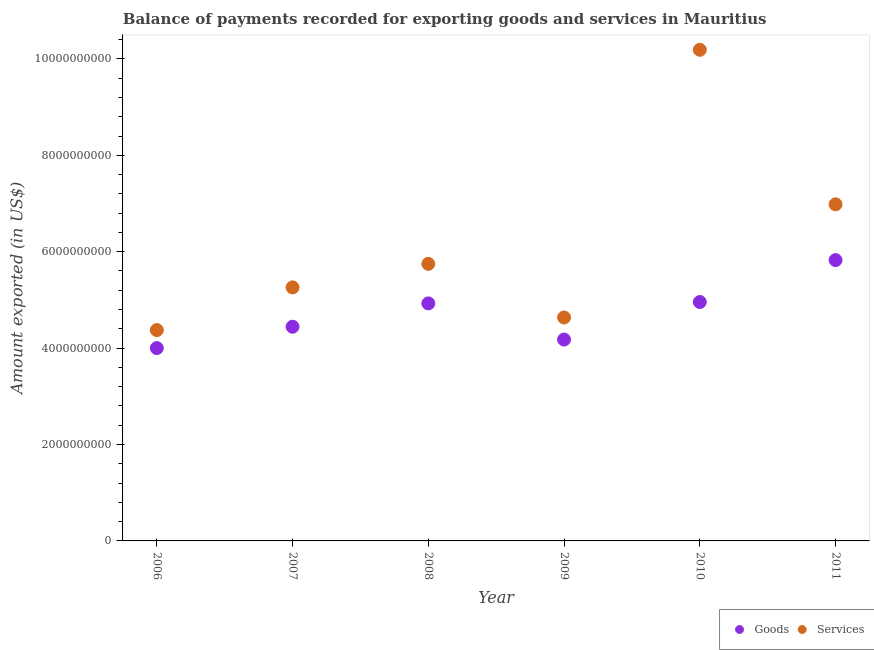How many different coloured dotlines are there?
Make the answer very short. 2. What is the amount of goods exported in 2007?
Your answer should be compact. 4.44e+09. Across all years, what is the maximum amount of goods exported?
Offer a very short reply. 5.83e+09. Across all years, what is the minimum amount of goods exported?
Make the answer very short. 4.00e+09. In which year was the amount of services exported maximum?
Your answer should be very brief. 2010. What is the total amount of services exported in the graph?
Provide a short and direct response. 3.72e+1. What is the difference between the amount of goods exported in 2008 and that in 2011?
Your answer should be compact. -8.98e+08. What is the difference between the amount of goods exported in 2010 and the amount of services exported in 2008?
Offer a terse response. -7.91e+08. What is the average amount of goods exported per year?
Offer a very short reply. 4.72e+09. In the year 2007, what is the difference between the amount of services exported and amount of goods exported?
Provide a succinct answer. 8.16e+08. What is the ratio of the amount of goods exported in 2008 to that in 2009?
Make the answer very short. 1.18. Is the difference between the amount of goods exported in 2006 and 2008 greater than the difference between the amount of services exported in 2006 and 2008?
Your answer should be very brief. Yes. What is the difference between the highest and the second highest amount of services exported?
Your response must be concise. 3.21e+09. What is the difference between the highest and the lowest amount of goods exported?
Keep it short and to the point. 1.83e+09. In how many years, is the amount of goods exported greater than the average amount of goods exported taken over all years?
Your response must be concise. 3. Is the sum of the amount of services exported in 2010 and 2011 greater than the maximum amount of goods exported across all years?
Keep it short and to the point. Yes. Does the amount of goods exported monotonically increase over the years?
Your response must be concise. No. Is the amount of goods exported strictly greater than the amount of services exported over the years?
Your answer should be compact. No. Is the amount of services exported strictly less than the amount of goods exported over the years?
Provide a succinct answer. No. How many dotlines are there?
Provide a short and direct response. 2. What is the difference between two consecutive major ticks on the Y-axis?
Your answer should be compact. 2.00e+09. Where does the legend appear in the graph?
Your response must be concise. Bottom right. How are the legend labels stacked?
Provide a short and direct response. Horizontal. What is the title of the graph?
Keep it short and to the point. Balance of payments recorded for exporting goods and services in Mauritius. Does "International Visitors" appear as one of the legend labels in the graph?
Give a very brief answer. No. What is the label or title of the Y-axis?
Keep it short and to the point. Amount exported (in US$). What is the Amount exported (in US$) of Goods in 2006?
Provide a short and direct response. 4.00e+09. What is the Amount exported (in US$) of Services in 2006?
Offer a very short reply. 4.37e+09. What is the Amount exported (in US$) in Goods in 2007?
Provide a succinct answer. 4.44e+09. What is the Amount exported (in US$) of Services in 2007?
Your response must be concise. 5.26e+09. What is the Amount exported (in US$) in Goods in 2008?
Ensure brevity in your answer.  4.93e+09. What is the Amount exported (in US$) in Services in 2008?
Provide a short and direct response. 5.75e+09. What is the Amount exported (in US$) of Goods in 2009?
Keep it short and to the point. 4.18e+09. What is the Amount exported (in US$) in Services in 2009?
Make the answer very short. 4.64e+09. What is the Amount exported (in US$) of Goods in 2010?
Offer a terse response. 4.96e+09. What is the Amount exported (in US$) of Services in 2010?
Your answer should be very brief. 1.02e+1. What is the Amount exported (in US$) in Goods in 2011?
Give a very brief answer. 5.83e+09. What is the Amount exported (in US$) of Services in 2011?
Your response must be concise. 6.98e+09. Across all years, what is the maximum Amount exported (in US$) in Goods?
Keep it short and to the point. 5.83e+09. Across all years, what is the maximum Amount exported (in US$) in Services?
Provide a short and direct response. 1.02e+1. Across all years, what is the minimum Amount exported (in US$) in Goods?
Give a very brief answer. 4.00e+09. Across all years, what is the minimum Amount exported (in US$) of Services?
Provide a succinct answer. 4.37e+09. What is the total Amount exported (in US$) in Goods in the graph?
Ensure brevity in your answer.  2.83e+1. What is the total Amount exported (in US$) in Services in the graph?
Your answer should be compact. 3.72e+1. What is the difference between the Amount exported (in US$) in Goods in 2006 and that in 2007?
Ensure brevity in your answer.  -4.43e+08. What is the difference between the Amount exported (in US$) in Services in 2006 and that in 2007?
Provide a succinct answer. -8.85e+08. What is the difference between the Amount exported (in US$) of Goods in 2006 and that in 2008?
Your answer should be very brief. -9.28e+08. What is the difference between the Amount exported (in US$) of Services in 2006 and that in 2008?
Your response must be concise. -1.37e+09. What is the difference between the Amount exported (in US$) of Goods in 2006 and that in 2009?
Your response must be concise. -1.77e+08. What is the difference between the Amount exported (in US$) in Services in 2006 and that in 2009?
Give a very brief answer. -2.61e+08. What is the difference between the Amount exported (in US$) in Goods in 2006 and that in 2010?
Offer a terse response. -9.56e+08. What is the difference between the Amount exported (in US$) of Services in 2006 and that in 2010?
Provide a short and direct response. -5.81e+09. What is the difference between the Amount exported (in US$) of Goods in 2006 and that in 2011?
Give a very brief answer. -1.83e+09. What is the difference between the Amount exported (in US$) in Services in 2006 and that in 2011?
Your answer should be compact. -2.61e+09. What is the difference between the Amount exported (in US$) of Goods in 2007 and that in 2008?
Provide a short and direct response. -4.85e+08. What is the difference between the Amount exported (in US$) in Services in 2007 and that in 2008?
Make the answer very short. -4.88e+08. What is the difference between the Amount exported (in US$) in Goods in 2007 and that in 2009?
Give a very brief answer. 2.66e+08. What is the difference between the Amount exported (in US$) in Services in 2007 and that in 2009?
Give a very brief answer. 6.24e+08. What is the difference between the Amount exported (in US$) in Goods in 2007 and that in 2010?
Provide a succinct answer. -5.14e+08. What is the difference between the Amount exported (in US$) in Services in 2007 and that in 2010?
Offer a very short reply. -4.93e+09. What is the difference between the Amount exported (in US$) in Goods in 2007 and that in 2011?
Offer a very short reply. -1.38e+09. What is the difference between the Amount exported (in US$) in Services in 2007 and that in 2011?
Provide a succinct answer. -1.72e+09. What is the difference between the Amount exported (in US$) of Goods in 2008 and that in 2009?
Give a very brief answer. 7.50e+08. What is the difference between the Amount exported (in US$) in Services in 2008 and that in 2009?
Offer a terse response. 1.11e+09. What is the difference between the Amount exported (in US$) in Goods in 2008 and that in 2010?
Offer a very short reply. -2.88e+07. What is the difference between the Amount exported (in US$) in Services in 2008 and that in 2010?
Offer a very short reply. -4.44e+09. What is the difference between the Amount exported (in US$) of Goods in 2008 and that in 2011?
Ensure brevity in your answer.  -8.98e+08. What is the difference between the Amount exported (in US$) of Services in 2008 and that in 2011?
Provide a short and direct response. -1.24e+09. What is the difference between the Amount exported (in US$) of Goods in 2009 and that in 2010?
Offer a terse response. -7.79e+08. What is the difference between the Amount exported (in US$) of Services in 2009 and that in 2010?
Offer a terse response. -5.55e+09. What is the difference between the Amount exported (in US$) of Goods in 2009 and that in 2011?
Your answer should be very brief. -1.65e+09. What is the difference between the Amount exported (in US$) in Services in 2009 and that in 2011?
Your answer should be compact. -2.35e+09. What is the difference between the Amount exported (in US$) of Goods in 2010 and that in 2011?
Keep it short and to the point. -8.69e+08. What is the difference between the Amount exported (in US$) in Services in 2010 and that in 2011?
Offer a terse response. 3.21e+09. What is the difference between the Amount exported (in US$) in Goods in 2006 and the Amount exported (in US$) in Services in 2007?
Your answer should be very brief. -1.26e+09. What is the difference between the Amount exported (in US$) in Goods in 2006 and the Amount exported (in US$) in Services in 2008?
Make the answer very short. -1.75e+09. What is the difference between the Amount exported (in US$) in Goods in 2006 and the Amount exported (in US$) in Services in 2009?
Keep it short and to the point. -6.35e+08. What is the difference between the Amount exported (in US$) of Goods in 2006 and the Amount exported (in US$) of Services in 2010?
Provide a succinct answer. -6.19e+09. What is the difference between the Amount exported (in US$) of Goods in 2006 and the Amount exported (in US$) of Services in 2011?
Provide a succinct answer. -2.98e+09. What is the difference between the Amount exported (in US$) in Goods in 2007 and the Amount exported (in US$) in Services in 2008?
Your answer should be very brief. -1.30e+09. What is the difference between the Amount exported (in US$) of Goods in 2007 and the Amount exported (in US$) of Services in 2009?
Your answer should be compact. -1.92e+08. What is the difference between the Amount exported (in US$) of Goods in 2007 and the Amount exported (in US$) of Services in 2010?
Ensure brevity in your answer.  -5.75e+09. What is the difference between the Amount exported (in US$) of Goods in 2007 and the Amount exported (in US$) of Services in 2011?
Ensure brevity in your answer.  -2.54e+09. What is the difference between the Amount exported (in US$) in Goods in 2008 and the Amount exported (in US$) in Services in 2009?
Your response must be concise. 2.93e+08. What is the difference between the Amount exported (in US$) of Goods in 2008 and the Amount exported (in US$) of Services in 2010?
Provide a succinct answer. -5.26e+09. What is the difference between the Amount exported (in US$) of Goods in 2008 and the Amount exported (in US$) of Services in 2011?
Provide a succinct answer. -2.06e+09. What is the difference between the Amount exported (in US$) in Goods in 2009 and the Amount exported (in US$) in Services in 2010?
Your answer should be compact. -6.01e+09. What is the difference between the Amount exported (in US$) of Goods in 2009 and the Amount exported (in US$) of Services in 2011?
Keep it short and to the point. -2.81e+09. What is the difference between the Amount exported (in US$) of Goods in 2010 and the Amount exported (in US$) of Services in 2011?
Offer a very short reply. -2.03e+09. What is the average Amount exported (in US$) in Goods per year?
Your answer should be compact. 4.72e+09. What is the average Amount exported (in US$) in Services per year?
Make the answer very short. 6.20e+09. In the year 2006, what is the difference between the Amount exported (in US$) of Goods and Amount exported (in US$) of Services?
Your response must be concise. -3.74e+08. In the year 2007, what is the difference between the Amount exported (in US$) in Goods and Amount exported (in US$) in Services?
Offer a very short reply. -8.16e+08. In the year 2008, what is the difference between the Amount exported (in US$) of Goods and Amount exported (in US$) of Services?
Your response must be concise. -8.20e+08. In the year 2009, what is the difference between the Amount exported (in US$) in Goods and Amount exported (in US$) in Services?
Your answer should be very brief. -4.58e+08. In the year 2010, what is the difference between the Amount exported (in US$) in Goods and Amount exported (in US$) in Services?
Make the answer very short. -5.23e+09. In the year 2011, what is the difference between the Amount exported (in US$) in Goods and Amount exported (in US$) in Services?
Offer a terse response. -1.16e+09. What is the ratio of the Amount exported (in US$) in Goods in 2006 to that in 2007?
Your answer should be compact. 0.9. What is the ratio of the Amount exported (in US$) in Services in 2006 to that in 2007?
Provide a succinct answer. 0.83. What is the ratio of the Amount exported (in US$) in Goods in 2006 to that in 2008?
Provide a short and direct response. 0.81. What is the ratio of the Amount exported (in US$) in Services in 2006 to that in 2008?
Provide a short and direct response. 0.76. What is the ratio of the Amount exported (in US$) in Goods in 2006 to that in 2009?
Ensure brevity in your answer.  0.96. What is the ratio of the Amount exported (in US$) of Services in 2006 to that in 2009?
Make the answer very short. 0.94. What is the ratio of the Amount exported (in US$) in Goods in 2006 to that in 2010?
Offer a very short reply. 0.81. What is the ratio of the Amount exported (in US$) of Services in 2006 to that in 2010?
Provide a succinct answer. 0.43. What is the ratio of the Amount exported (in US$) of Goods in 2006 to that in 2011?
Your response must be concise. 0.69. What is the ratio of the Amount exported (in US$) in Services in 2006 to that in 2011?
Keep it short and to the point. 0.63. What is the ratio of the Amount exported (in US$) of Goods in 2007 to that in 2008?
Provide a succinct answer. 0.9. What is the ratio of the Amount exported (in US$) in Services in 2007 to that in 2008?
Ensure brevity in your answer.  0.92. What is the ratio of the Amount exported (in US$) in Goods in 2007 to that in 2009?
Offer a very short reply. 1.06. What is the ratio of the Amount exported (in US$) in Services in 2007 to that in 2009?
Your answer should be very brief. 1.13. What is the ratio of the Amount exported (in US$) of Goods in 2007 to that in 2010?
Provide a short and direct response. 0.9. What is the ratio of the Amount exported (in US$) in Services in 2007 to that in 2010?
Your response must be concise. 0.52. What is the ratio of the Amount exported (in US$) in Goods in 2007 to that in 2011?
Make the answer very short. 0.76. What is the ratio of the Amount exported (in US$) in Services in 2007 to that in 2011?
Provide a short and direct response. 0.75. What is the ratio of the Amount exported (in US$) in Goods in 2008 to that in 2009?
Provide a short and direct response. 1.18. What is the ratio of the Amount exported (in US$) of Services in 2008 to that in 2009?
Provide a succinct answer. 1.24. What is the ratio of the Amount exported (in US$) in Goods in 2008 to that in 2010?
Offer a terse response. 0.99. What is the ratio of the Amount exported (in US$) in Services in 2008 to that in 2010?
Your response must be concise. 0.56. What is the ratio of the Amount exported (in US$) of Goods in 2008 to that in 2011?
Make the answer very short. 0.85. What is the ratio of the Amount exported (in US$) in Services in 2008 to that in 2011?
Offer a terse response. 0.82. What is the ratio of the Amount exported (in US$) in Goods in 2009 to that in 2010?
Offer a terse response. 0.84. What is the ratio of the Amount exported (in US$) in Services in 2009 to that in 2010?
Give a very brief answer. 0.45. What is the ratio of the Amount exported (in US$) in Goods in 2009 to that in 2011?
Provide a short and direct response. 0.72. What is the ratio of the Amount exported (in US$) in Services in 2009 to that in 2011?
Offer a very short reply. 0.66. What is the ratio of the Amount exported (in US$) in Goods in 2010 to that in 2011?
Your answer should be compact. 0.85. What is the ratio of the Amount exported (in US$) of Services in 2010 to that in 2011?
Your response must be concise. 1.46. What is the difference between the highest and the second highest Amount exported (in US$) of Goods?
Provide a succinct answer. 8.69e+08. What is the difference between the highest and the second highest Amount exported (in US$) of Services?
Provide a succinct answer. 3.21e+09. What is the difference between the highest and the lowest Amount exported (in US$) in Goods?
Your answer should be very brief. 1.83e+09. What is the difference between the highest and the lowest Amount exported (in US$) of Services?
Make the answer very short. 5.81e+09. 